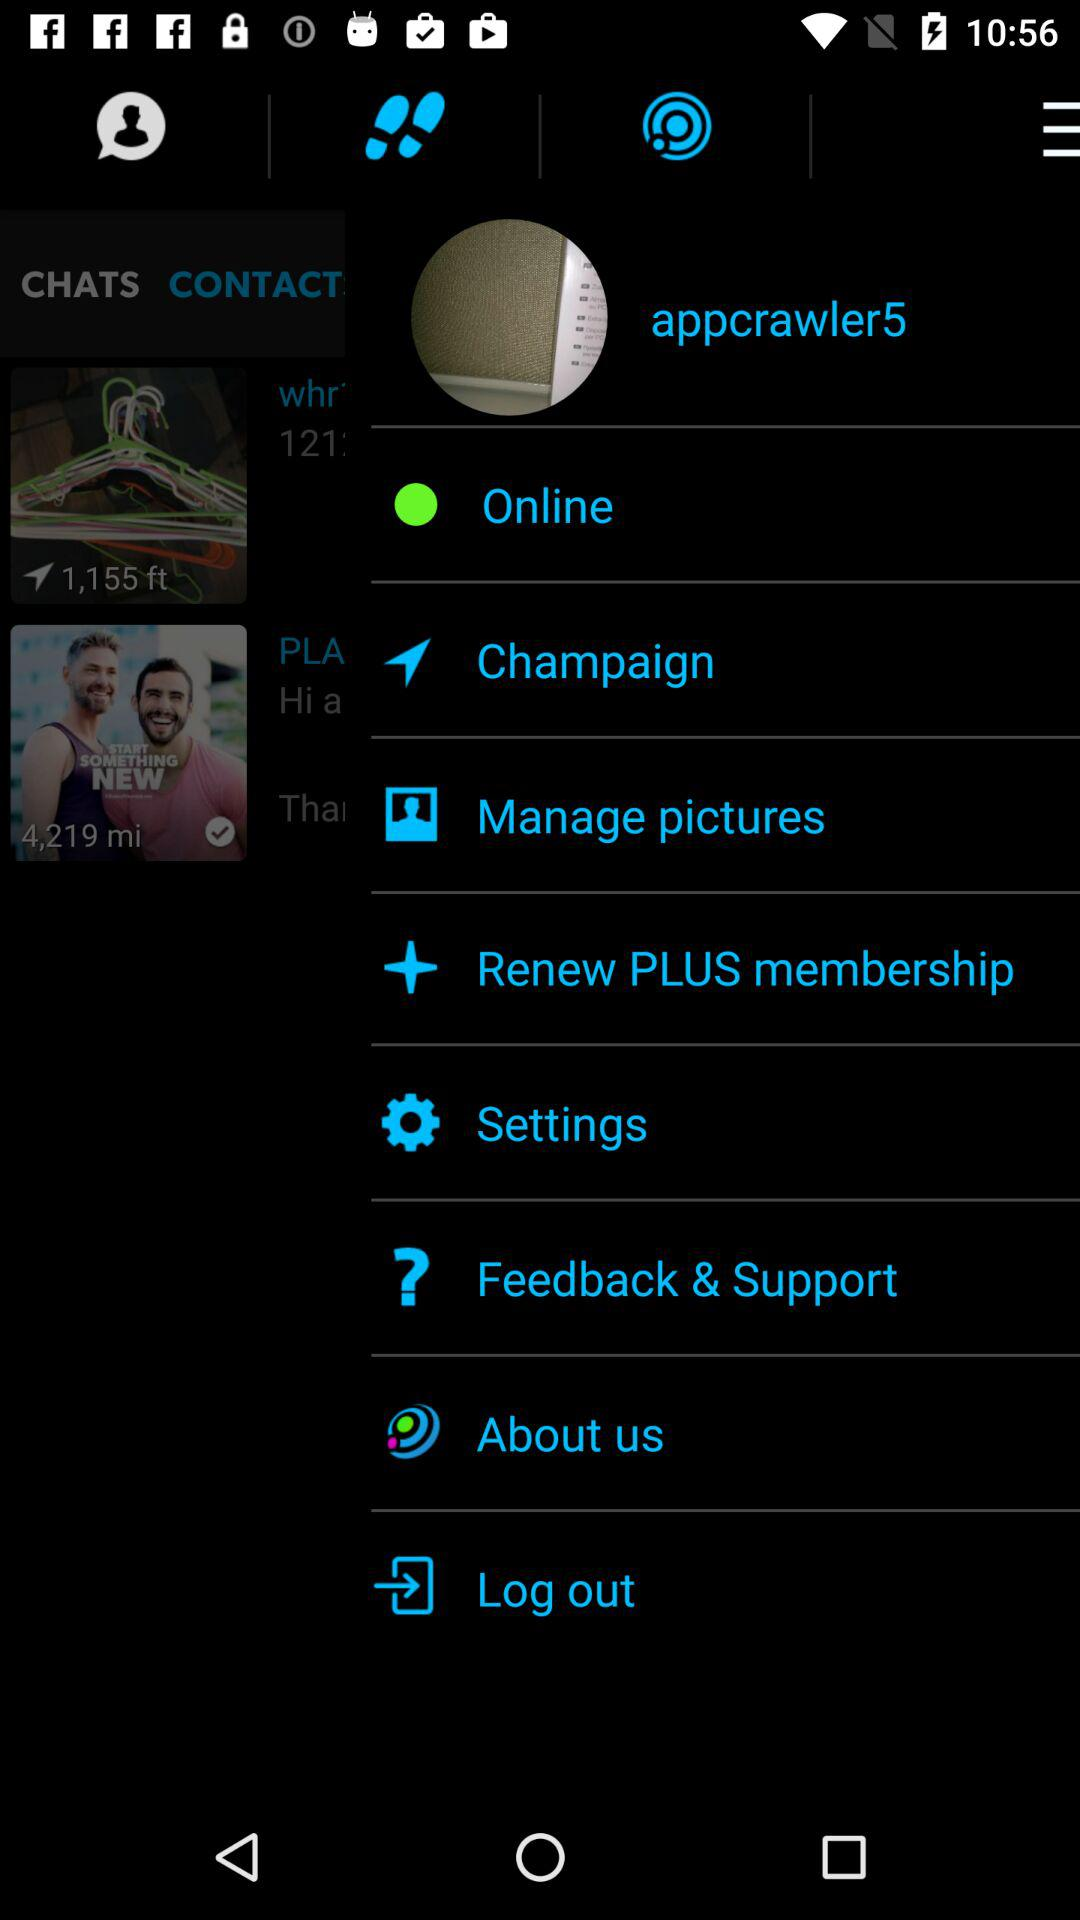What is the user profile name? The user profile name is "appcrawler5". 